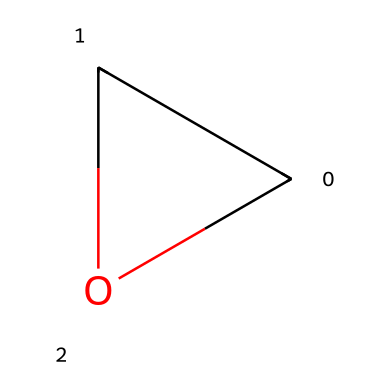What is the molecular formula of ethylene oxide? The SMILES representation indicates a structure with two carbon atoms (C), two oxygen atoms (O), leading to a molecular formula of C2H4O.
Answer: C2H4O How many rings are present in the chemical structure? The SMILES notation "C1CO1" indicates a cyclic structure, as the '1' denotes a ring closure, confirming one ring is present.
Answer: 1 What type of bonding is evident in ethylene oxide? The presence of carbon and oxygen atoms indicates covalent bonding, as these atoms share electrons to form stable bonds.
Answer: covalent What is the most prominent functional group in ethylene oxide? The oxygen atom in the structure, which is part of an ether functional group (−O−) connecting the two carbon atoms, is the most prominent functional group.
Answer: ether What is the degree of saturation of ethylene oxide? Evaluating the structure reveals no triple bonds and one ring, leading to a degree of saturation of 1, allowing for connectivity without further saturation due to available bonding configurations.
Answer: 1 Is ethylene oxide a polar or nonpolar molecule? The presence of the electronegative oxygen atom in a relatively symmetrical structure indicates that although it has polar bonds, the overall molecule can exhibit properties leaning toward being polar due to molecular geometry.
Answer: polar 